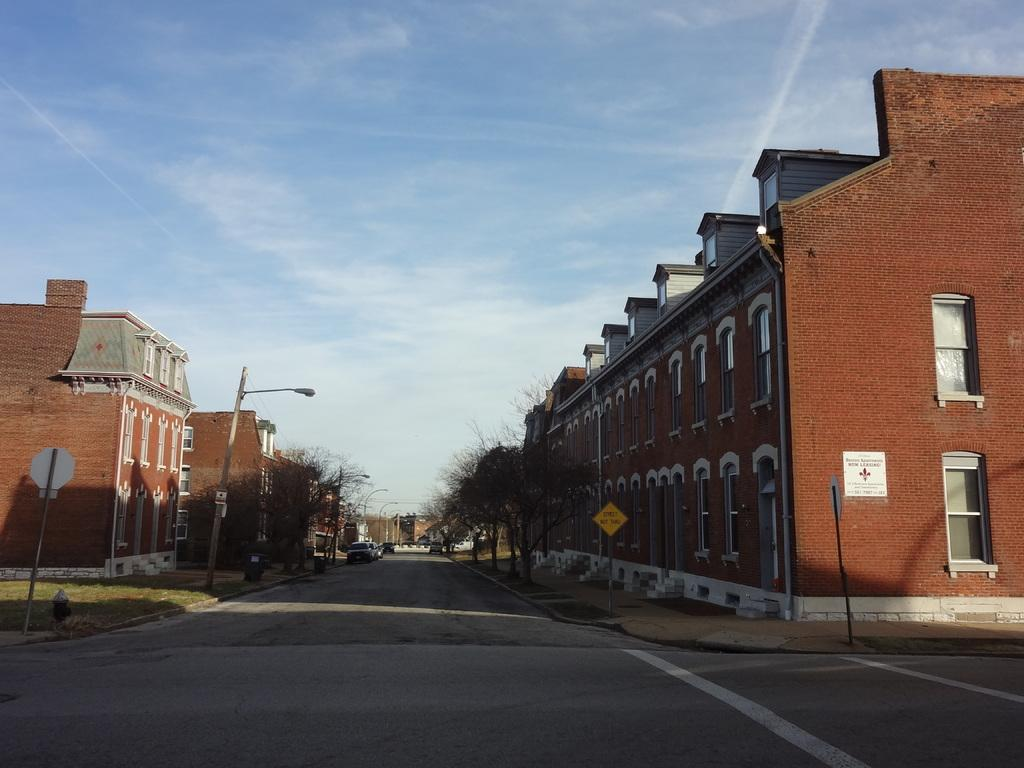What type of structures can be seen in the image? There are buildings in the image. What is happening on the road in the image? Motor vehicles are present on the road in the image. What type of signs can be seen in the image? Sign boards are visible boards are visible in the image. What type of poles are present in the image? Street poles are present in the image. What type of lighting is visible in the image? Street lights are visible in the image. What type of vegetation is present in the image? Trees are present in the image. What part of the natural environment is visible in the image? The sky is visible in the image. What can be seen in the sky in the image? Clouds are present in the sky. What type of advertisement for beef can be seen on the bed in the image? There is no bed or advertisement for beef present in the image. What type of beef is being served on the street pole in the image? There is no beef or street pole serving beef present in the image. 